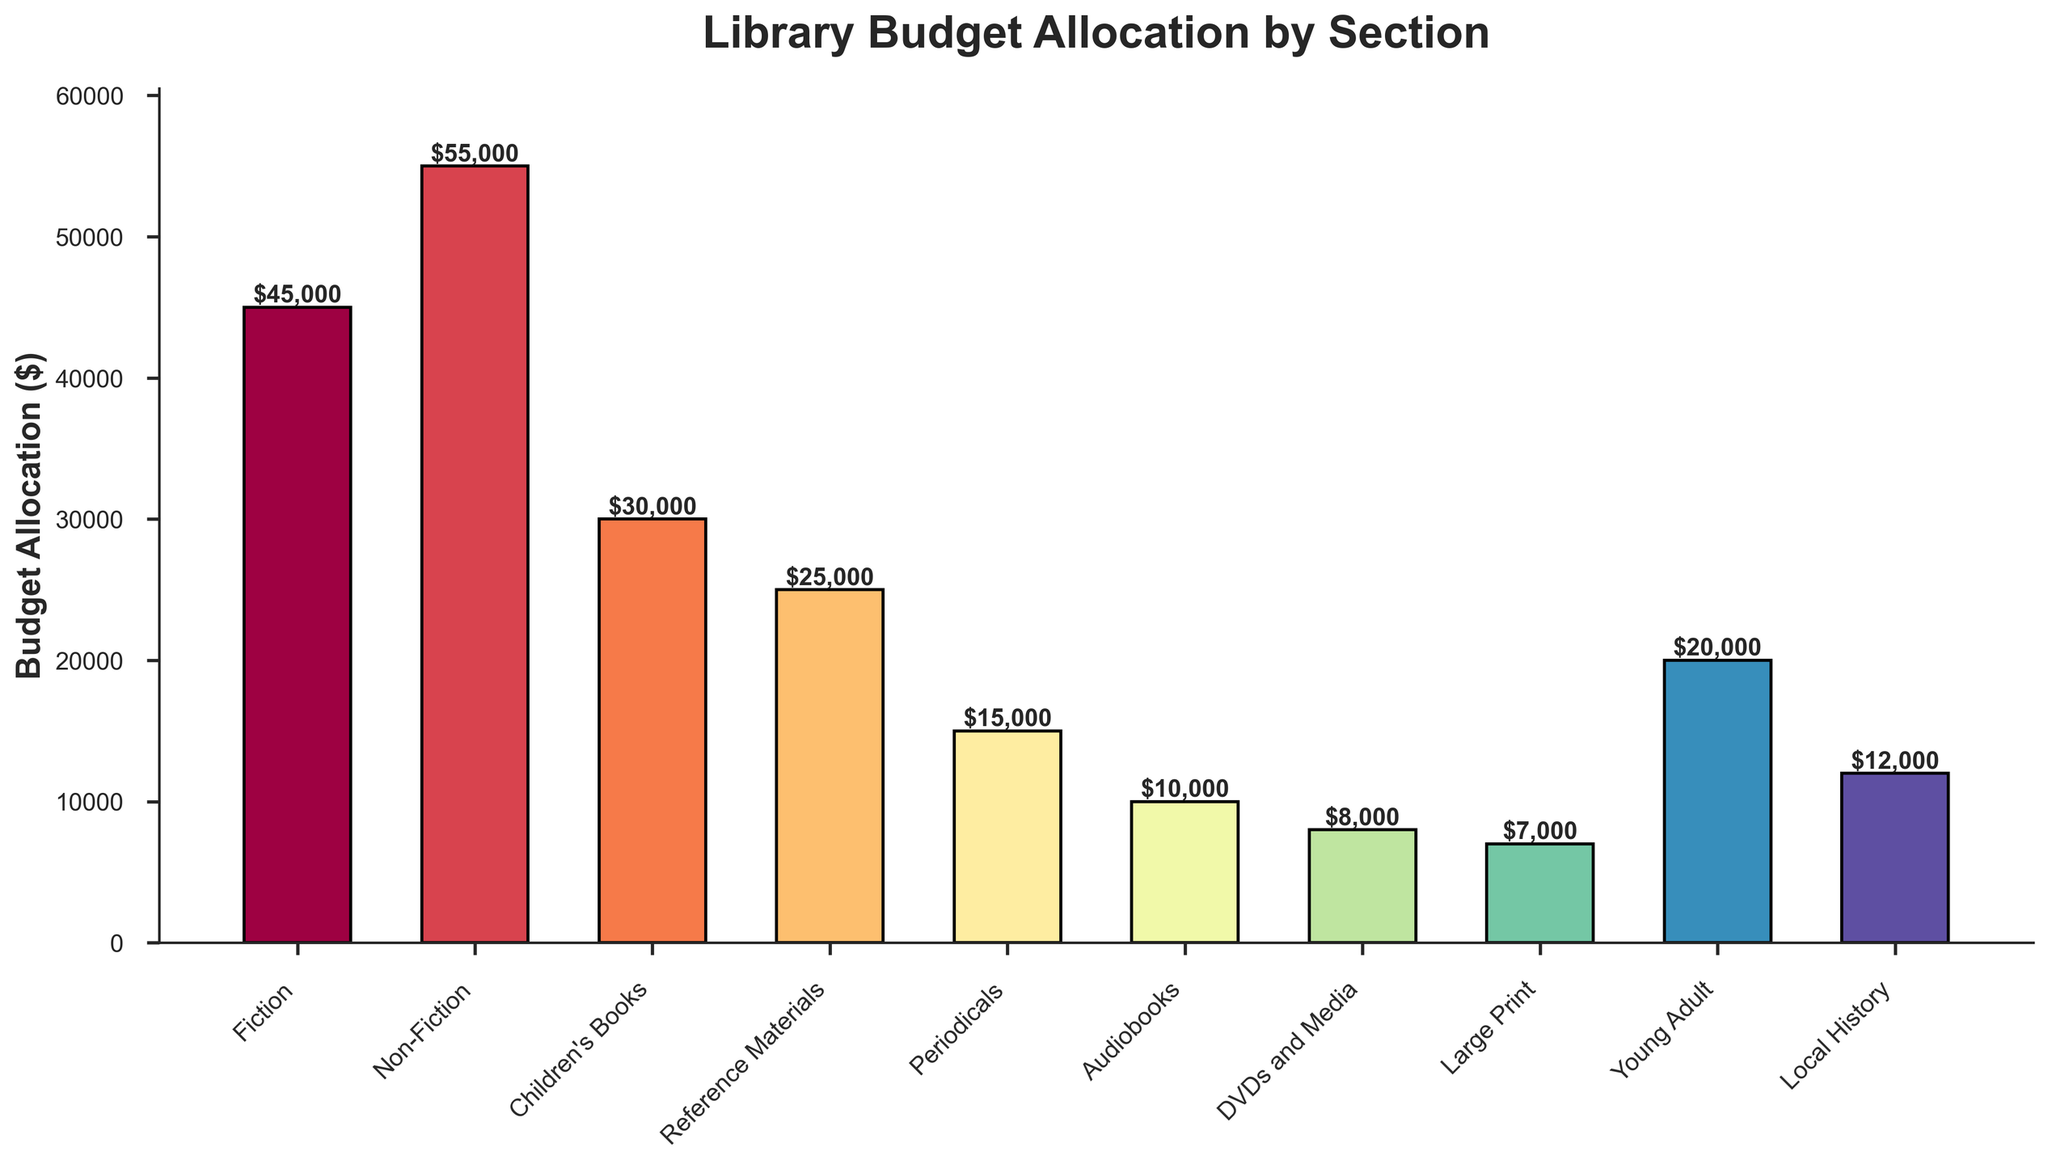Which section has the highest budget allocation? The section with the highest budget allocation will be the tallest bar in the chart. Looking at the plot, the "Non-Fiction" bar is the tallest.
Answer: Non-Fiction Which sections have a budget allocation lower than $10,000? By inspecting the bar chart, the bars for "Audiobooks" ($10,000) and "DVDs and Media" ($8,000) are below the $10,000 mark.
Answer: DVDs and Media What is the total budget allocated for Fiction and Non-Fiction sections? To find this, sum the budgets for "Fiction" and "Non-Fiction." (Fiction: $45,000 + Non-Fiction: $55,000)
Answer: $100,000 How does the budget for Children's Books compare to Local History? Compare the heights of the bars for "Children's Books" and "Local History." Children's Books has a budget of $30,000, whereas Local History has $12,000.
Answer: Children's Books is higher What is the difference in budget allocation between the highest and the lowest budget sections? The highest budget section is Non-Fiction ($55,000), and the lowest is Large Print ($7,000). Calculate the difference: $55,000 - $7,000.
Answer: $48,000 What is the average budget allocation for the sections? Sum all the budget allocations and divide by the number of sections. Total budget allocation is $235,000, and there are 10 sections. So, $235,000 / 10 = $23,500.
Answer: $23,500 Which sections' budget falls between $10,000 and $25,000? By inspecting the bars, the sections falling between $10,000 and $25,000 are "Reference Materials" ($25,000), "Periodicals" ($15,000), "Local History" ($12,000).
Answer: Reference Materials, Periodicals, Local History What is the combined budget for all sections other than Fiction and Non-Fiction? First, sum all the budgets: $235,000. Then subtract Fiction ($45,000) and Non-Fiction ($55,000): $235,000 - $100,000.
Answer: $135,000 How many sections have a budget allocation of $20,000 or more? We need to count the number of bars that are positioned at or above the $20,000 mark. By inspecting, we see 4 sections: Fiction, Non-Fiction, Children's Books, and Young Adult.
Answer: 4 Which section has the second lowest budget allocation? By comparing the heights of the smaller bars, the second lowest bar after Large Print ($7,000) is for DVDs and Media ($8,000).
Answer: DVDs and Media 